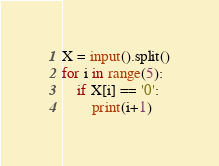<code> <loc_0><loc_0><loc_500><loc_500><_Python_>X = input().split()
for i in range(5):
	if X[i] == '0':
		print(i+1)</code> 